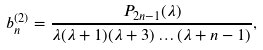Convert formula to latex. <formula><loc_0><loc_0><loc_500><loc_500>b _ { n } ^ { ( 2 ) } = \frac { P _ { 2 n - 1 } ( \lambda ) } { \lambda ( \lambda + 1 ) ( \lambda + 3 ) \dots ( \lambda + n - 1 ) } ,</formula> 